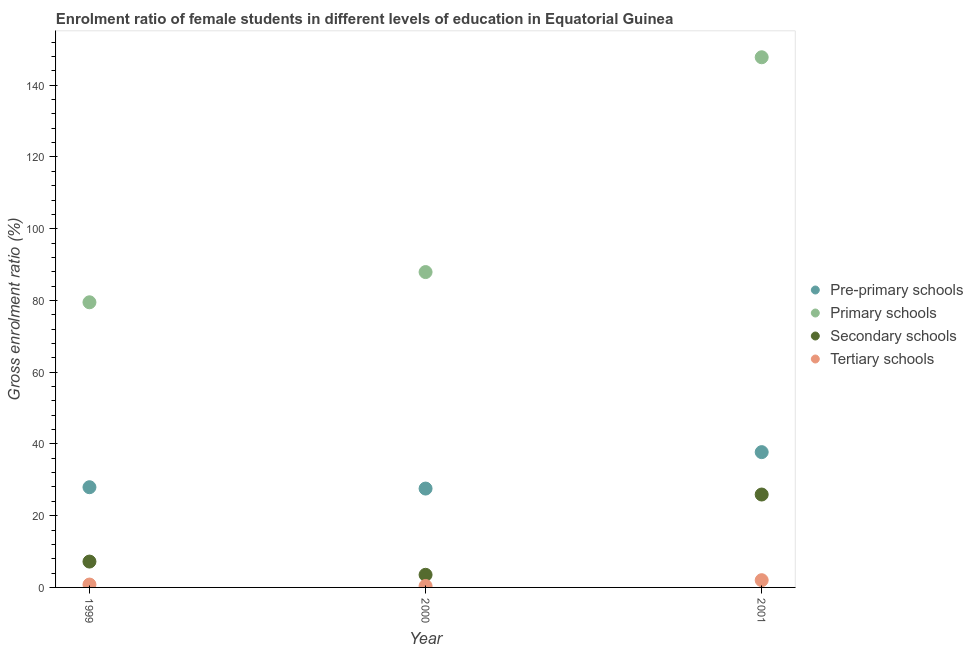What is the gross enrolment ratio(male) in secondary schools in 1999?
Give a very brief answer. 7.21. Across all years, what is the maximum gross enrolment ratio(male) in tertiary schools?
Offer a very short reply. 2.01. Across all years, what is the minimum gross enrolment ratio(male) in tertiary schools?
Ensure brevity in your answer.  0.4. What is the total gross enrolment ratio(male) in tertiary schools in the graph?
Make the answer very short. 3.21. What is the difference between the gross enrolment ratio(male) in tertiary schools in 1999 and that in 2001?
Offer a very short reply. -1.21. What is the difference between the gross enrolment ratio(male) in secondary schools in 2001 and the gross enrolment ratio(male) in primary schools in 2000?
Your response must be concise. -62.02. What is the average gross enrolment ratio(male) in tertiary schools per year?
Give a very brief answer. 1.07. In the year 1999, what is the difference between the gross enrolment ratio(male) in tertiary schools and gross enrolment ratio(male) in pre-primary schools?
Your answer should be very brief. -27.14. What is the ratio of the gross enrolment ratio(male) in primary schools in 2000 to that in 2001?
Your answer should be very brief. 0.59. Is the difference between the gross enrolment ratio(male) in secondary schools in 2000 and 2001 greater than the difference between the gross enrolment ratio(male) in primary schools in 2000 and 2001?
Offer a terse response. Yes. What is the difference between the highest and the second highest gross enrolment ratio(male) in primary schools?
Provide a succinct answer. 59.88. What is the difference between the highest and the lowest gross enrolment ratio(male) in tertiary schools?
Keep it short and to the point. 1.62. Is the sum of the gross enrolment ratio(male) in secondary schools in 2000 and 2001 greater than the maximum gross enrolment ratio(male) in primary schools across all years?
Your response must be concise. No. How many dotlines are there?
Give a very brief answer. 4. How many years are there in the graph?
Keep it short and to the point. 3. What is the difference between two consecutive major ticks on the Y-axis?
Your response must be concise. 20. Are the values on the major ticks of Y-axis written in scientific E-notation?
Ensure brevity in your answer.  No. Does the graph contain grids?
Provide a short and direct response. No. Where does the legend appear in the graph?
Keep it short and to the point. Center right. What is the title of the graph?
Offer a very short reply. Enrolment ratio of female students in different levels of education in Equatorial Guinea. What is the Gross enrolment ratio (%) in Pre-primary schools in 1999?
Offer a terse response. 27.94. What is the Gross enrolment ratio (%) in Primary schools in 1999?
Your answer should be very brief. 79.49. What is the Gross enrolment ratio (%) in Secondary schools in 1999?
Your answer should be very brief. 7.21. What is the Gross enrolment ratio (%) in Tertiary schools in 1999?
Ensure brevity in your answer.  0.8. What is the Gross enrolment ratio (%) in Pre-primary schools in 2000?
Your response must be concise. 27.56. What is the Gross enrolment ratio (%) in Primary schools in 2000?
Provide a short and direct response. 87.91. What is the Gross enrolment ratio (%) in Secondary schools in 2000?
Your answer should be compact. 3.52. What is the Gross enrolment ratio (%) in Tertiary schools in 2000?
Provide a succinct answer. 0.4. What is the Gross enrolment ratio (%) in Pre-primary schools in 2001?
Provide a short and direct response. 37.72. What is the Gross enrolment ratio (%) in Primary schools in 2001?
Your response must be concise. 147.8. What is the Gross enrolment ratio (%) in Secondary schools in 2001?
Give a very brief answer. 25.9. What is the Gross enrolment ratio (%) of Tertiary schools in 2001?
Give a very brief answer. 2.01. Across all years, what is the maximum Gross enrolment ratio (%) of Pre-primary schools?
Offer a very short reply. 37.72. Across all years, what is the maximum Gross enrolment ratio (%) of Primary schools?
Your answer should be very brief. 147.8. Across all years, what is the maximum Gross enrolment ratio (%) of Secondary schools?
Offer a very short reply. 25.9. Across all years, what is the maximum Gross enrolment ratio (%) in Tertiary schools?
Make the answer very short. 2.01. Across all years, what is the minimum Gross enrolment ratio (%) of Pre-primary schools?
Make the answer very short. 27.56. Across all years, what is the minimum Gross enrolment ratio (%) in Primary schools?
Your answer should be very brief. 79.49. Across all years, what is the minimum Gross enrolment ratio (%) of Secondary schools?
Ensure brevity in your answer.  3.52. Across all years, what is the minimum Gross enrolment ratio (%) in Tertiary schools?
Offer a terse response. 0.4. What is the total Gross enrolment ratio (%) in Pre-primary schools in the graph?
Your answer should be compact. 93.21. What is the total Gross enrolment ratio (%) in Primary schools in the graph?
Give a very brief answer. 315.2. What is the total Gross enrolment ratio (%) of Secondary schools in the graph?
Make the answer very short. 36.62. What is the total Gross enrolment ratio (%) in Tertiary schools in the graph?
Your answer should be very brief. 3.21. What is the difference between the Gross enrolment ratio (%) in Pre-primary schools in 1999 and that in 2000?
Provide a succinct answer. 0.38. What is the difference between the Gross enrolment ratio (%) in Primary schools in 1999 and that in 2000?
Offer a terse response. -8.42. What is the difference between the Gross enrolment ratio (%) of Secondary schools in 1999 and that in 2000?
Make the answer very short. 3.69. What is the difference between the Gross enrolment ratio (%) of Tertiary schools in 1999 and that in 2000?
Your response must be concise. 0.4. What is the difference between the Gross enrolment ratio (%) of Pre-primary schools in 1999 and that in 2001?
Offer a very short reply. -9.78. What is the difference between the Gross enrolment ratio (%) in Primary schools in 1999 and that in 2001?
Make the answer very short. -68.31. What is the difference between the Gross enrolment ratio (%) in Secondary schools in 1999 and that in 2001?
Provide a succinct answer. -18.69. What is the difference between the Gross enrolment ratio (%) in Tertiary schools in 1999 and that in 2001?
Provide a succinct answer. -1.21. What is the difference between the Gross enrolment ratio (%) of Pre-primary schools in 2000 and that in 2001?
Your answer should be very brief. -10.16. What is the difference between the Gross enrolment ratio (%) of Primary schools in 2000 and that in 2001?
Your answer should be very brief. -59.88. What is the difference between the Gross enrolment ratio (%) in Secondary schools in 2000 and that in 2001?
Your response must be concise. -22.38. What is the difference between the Gross enrolment ratio (%) in Tertiary schools in 2000 and that in 2001?
Make the answer very short. -1.62. What is the difference between the Gross enrolment ratio (%) of Pre-primary schools in 1999 and the Gross enrolment ratio (%) of Primary schools in 2000?
Keep it short and to the point. -59.98. What is the difference between the Gross enrolment ratio (%) in Pre-primary schools in 1999 and the Gross enrolment ratio (%) in Secondary schools in 2000?
Offer a very short reply. 24.42. What is the difference between the Gross enrolment ratio (%) in Pre-primary schools in 1999 and the Gross enrolment ratio (%) in Tertiary schools in 2000?
Make the answer very short. 27.54. What is the difference between the Gross enrolment ratio (%) of Primary schools in 1999 and the Gross enrolment ratio (%) of Secondary schools in 2000?
Provide a short and direct response. 75.97. What is the difference between the Gross enrolment ratio (%) of Primary schools in 1999 and the Gross enrolment ratio (%) of Tertiary schools in 2000?
Your response must be concise. 79.09. What is the difference between the Gross enrolment ratio (%) of Secondary schools in 1999 and the Gross enrolment ratio (%) of Tertiary schools in 2000?
Your answer should be very brief. 6.81. What is the difference between the Gross enrolment ratio (%) of Pre-primary schools in 1999 and the Gross enrolment ratio (%) of Primary schools in 2001?
Provide a short and direct response. -119.86. What is the difference between the Gross enrolment ratio (%) in Pre-primary schools in 1999 and the Gross enrolment ratio (%) in Secondary schools in 2001?
Ensure brevity in your answer.  2.04. What is the difference between the Gross enrolment ratio (%) of Pre-primary schools in 1999 and the Gross enrolment ratio (%) of Tertiary schools in 2001?
Your answer should be compact. 25.92. What is the difference between the Gross enrolment ratio (%) of Primary schools in 1999 and the Gross enrolment ratio (%) of Secondary schools in 2001?
Make the answer very short. 53.59. What is the difference between the Gross enrolment ratio (%) of Primary schools in 1999 and the Gross enrolment ratio (%) of Tertiary schools in 2001?
Make the answer very short. 77.48. What is the difference between the Gross enrolment ratio (%) of Secondary schools in 1999 and the Gross enrolment ratio (%) of Tertiary schools in 2001?
Offer a terse response. 5.19. What is the difference between the Gross enrolment ratio (%) in Pre-primary schools in 2000 and the Gross enrolment ratio (%) in Primary schools in 2001?
Ensure brevity in your answer.  -120.24. What is the difference between the Gross enrolment ratio (%) in Pre-primary schools in 2000 and the Gross enrolment ratio (%) in Secondary schools in 2001?
Ensure brevity in your answer.  1.66. What is the difference between the Gross enrolment ratio (%) of Pre-primary schools in 2000 and the Gross enrolment ratio (%) of Tertiary schools in 2001?
Your answer should be very brief. 25.55. What is the difference between the Gross enrolment ratio (%) of Primary schools in 2000 and the Gross enrolment ratio (%) of Secondary schools in 2001?
Provide a short and direct response. 62.02. What is the difference between the Gross enrolment ratio (%) of Primary schools in 2000 and the Gross enrolment ratio (%) of Tertiary schools in 2001?
Keep it short and to the point. 85.9. What is the difference between the Gross enrolment ratio (%) in Secondary schools in 2000 and the Gross enrolment ratio (%) in Tertiary schools in 2001?
Give a very brief answer. 1.5. What is the average Gross enrolment ratio (%) of Pre-primary schools per year?
Provide a succinct answer. 31.07. What is the average Gross enrolment ratio (%) in Primary schools per year?
Provide a short and direct response. 105.07. What is the average Gross enrolment ratio (%) of Secondary schools per year?
Offer a terse response. 12.21. What is the average Gross enrolment ratio (%) in Tertiary schools per year?
Give a very brief answer. 1.07. In the year 1999, what is the difference between the Gross enrolment ratio (%) of Pre-primary schools and Gross enrolment ratio (%) of Primary schools?
Your response must be concise. -51.55. In the year 1999, what is the difference between the Gross enrolment ratio (%) of Pre-primary schools and Gross enrolment ratio (%) of Secondary schools?
Make the answer very short. 20.73. In the year 1999, what is the difference between the Gross enrolment ratio (%) of Pre-primary schools and Gross enrolment ratio (%) of Tertiary schools?
Offer a terse response. 27.14. In the year 1999, what is the difference between the Gross enrolment ratio (%) in Primary schools and Gross enrolment ratio (%) in Secondary schools?
Make the answer very short. 72.28. In the year 1999, what is the difference between the Gross enrolment ratio (%) of Primary schools and Gross enrolment ratio (%) of Tertiary schools?
Provide a short and direct response. 78.69. In the year 1999, what is the difference between the Gross enrolment ratio (%) in Secondary schools and Gross enrolment ratio (%) in Tertiary schools?
Offer a terse response. 6.41. In the year 2000, what is the difference between the Gross enrolment ratio (%) in Pre-primary schools and Gross enrolment ratio (%) in Primary schools?
Keep it short and to the point. -60.35. In the year 2000, what is the difference between the Gross enrolment ratio (%) in Pre-primary schools and Gross enrolment ratio (%) in Secondary schools?
Offer a very short reply. 24.04. In the year 2000, what is the difference between the Gross enrolment ratio (%) in Pre-primary schools and Gross enrolment ratio (%) in Tertiary schools?
Give a very brief answer. 27.16. In the year 2000, what is the difference between the Gross enrolment ratio (%) in Primary schools and Gross enrolment ratio (%) in Secondary schools?
Your answer should be very brief. 84.4. In the year 2000, what is the difference between the Gross enrolment ratio (%) in Primary schools and Gross enrolment ratio (%) in Tertiary schools?
Make the answer very short. 87.52. In the year 2000, what is the difference between the Gross enrolment ratio (%) of Secondary schools and Gross enrolment ratio (%) of Tertiary schools?
Your answer should be compact. 3.12. In the year 2001, what is the difference between the Gross enrolment ratio (%) of Pre-primary schools and Gross enrolment ratio (%) of Primary schools?
Your answer should be very brief. -110.08. In the year 2001, what is the difference between the Gross enrolment ratio (%) in Pre-primary schools and Gross enrolment ratio (%) in Secondary schools?
Offer a terse response. 11.82. In the year 2001, what is the difference between the Gross enrolment ratio (%) of Pre-primary schools and Gross enrolment ratio (%) of Tertiary schools?
Make the answer very short. 35.7. In the year 2001, what is the difference between the Gross enrolment ratio (%) in Primary schools and Gross enrolment ratio (%) in Secondary schools?
Ensure brevity in your answer.  121.9. In the year 2001, what is the difference between the Gross enrolment ratio (%) in Primary schools and Gross enrolment ratio (%) in Tertiary schools?
Offer a terse response. 145.78. In the year 2001, what is the difference between the Gross enrolment ratio (%) in Secondary schools and Gross enrolment ratio (%) in Tertiary schools?
Offer a terse response. 23.88. What is the ratio of the Gross enrolment ratio (%) of Pre-primary schools in 1999 to that in 2000?
Keep it short and to the point. 1.01. What is the ratio of the Gross enrolment ratio (%) in Primary schools in 1999 to that in 2000?
Make the answer very short. 0.9. What is the ratio of the Gross enrolment ratio (%) of Secondary schools in 1999 to that in 2000?
Offer a very short reply. 2.05. What is the ratio of the Gross enrolment ratio (%) in Tertiary schools in 1999 to that in 2000?
Keep it short and to the point. 2.01. What is the ratio of the Gross enrolment ratio (%) of Pre-primary schools in 1999 to that in 2001?
Provide a succinct answer. 0.74. What is the ratio of the Gross enrolment ratio (%) of Primary schools in 1999 to that in 2001?
Your response must be concise. 0.54. What is the ratio of the Gross enrolment ratio (%) in Secondary schools in 1999 to that in 2001?
Provide a short and direct response. 0.28. What is the ratio of the Gross enrolment ratio (%) in Tertiary schools in 1999 to that in 2001?
Make the answer very short. 0.4. What is the ratio of the Gross enrolment ratio (%) in Pre-primary schools in 2000 to that in 2001?
Keep it short and to the point. 0.73. What is the ratio of the Gross enrolment ratio (%) of Primary schools in 2000 to that in 2001?
Provide a succinct answer. 0.59. What is the ratio of the Gross enrolment ratio (%) of Secondary schools in 2000 to that in 2001?
Offer a terse response. 0.14. What is the ratio of the Gross enrolment ratio (%) in Tertiary schools in 2000 to that in 2001?
Provide a succinct answer. 0.2. What is the difference between the highest and the second highest Gross enrolment ratio (%) of Pre-primary schools?
Give a very brief answer. 9.78. What is the difference between the highest and the second highest Gross enrolment ratio (%) of Primary schools?
Your answer should be very brief. 59.88. What is the difference between the highest and the second highest Gross enrolment ratio (%) of Secondary schools?
Provide a succinct answer. 18.69. What is the difference between the highest and the second highest Gross enrolment ratio (%) of Tertiary schools?
Keep it short and to the point. 1.21. What is the difference between the highest and the lowest Gross enrolment ratio (%) in Pre-primary schools?
Offer a terse response. 10.16. What is the difference between the highest and the lowest Gross enrolment ratio (%) of Primary schools?
Give a very brief answer. 68.31. What is the difference between the highest and the lowest Gross enrolment ratio (%) in Secondary schools?
Provide a succinct answer. 22.38. What is the difference between the highest and the lowest Gross enrolment ratio (%) of Tertiary schools?
Ensure brevity in your answer.  1.62. 